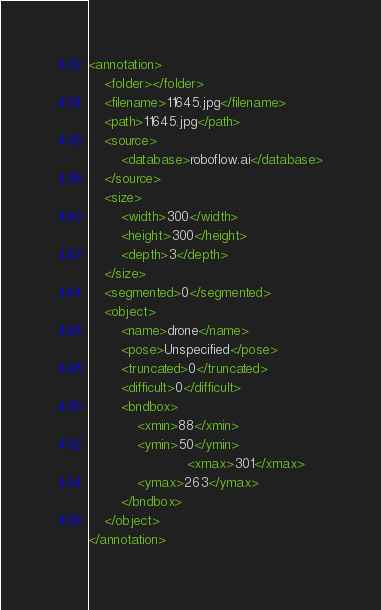Convert code to text. <code><loc_0><loc_0><loc_500><loc_500><_XML_><annotation>
	<folder></folder>
	<filename>11645.jpg</filename>
	<path>11645.jpg</path>
	<source>
		<database>roboflow.ai</database>
	</source>
	<size>
		<width>300</width>
		<height>300</height>
		<depth>3</depth>
	</size>
	<segmented>0</segmented>
	<object>
		<name>drone</name>
		<pose>Unspecified</pose>
		<truncated>0</truncated>
		<difficult>0</difficult>
		<bndbox>
			<xmin>88</xmin>
			<ymin>50</ymin>
                        <xmax>301</xmax>
			<ymax>263</ymax>
		</bndbox>
	</object>
</annotation>
</code> 